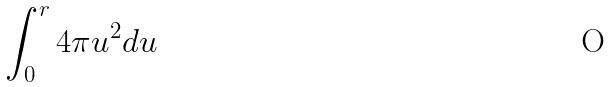<formula> <loc_0><loc_0><loc_500><loc_500>\int _ { 0 } ^ { r } 4 \pi u ^ { 2 } d u</formula> 